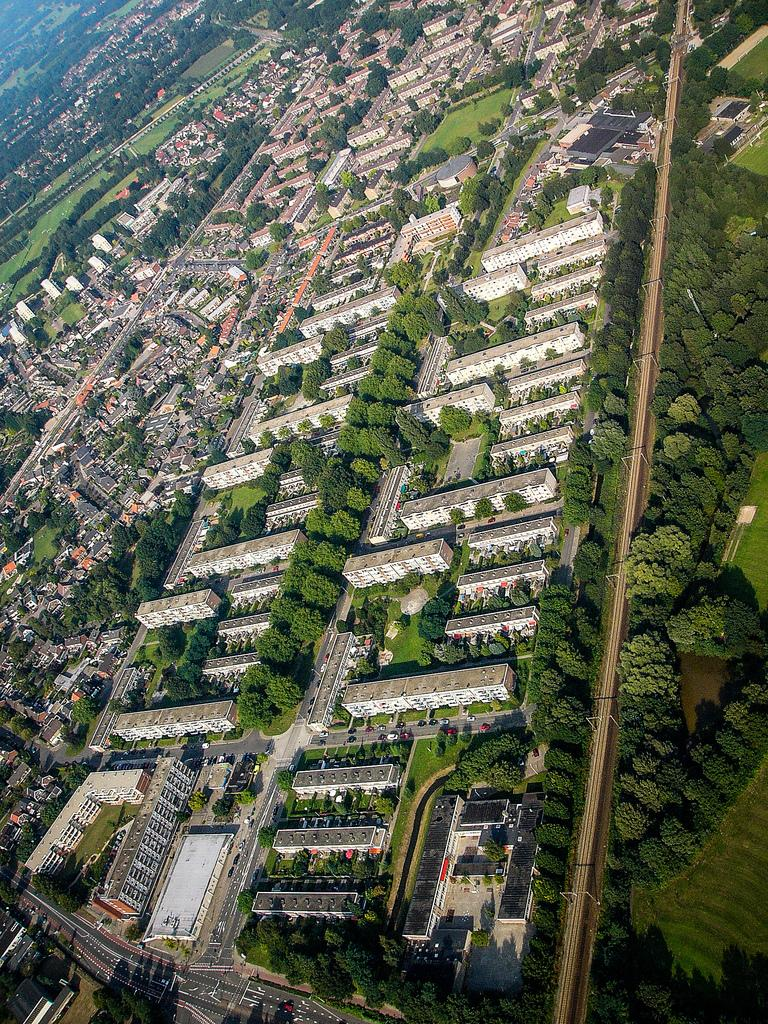What type of structures can be seen in the image? There are buildings in the image. What natural elements are present in the image? There are trees in the image. What man-made objects can be seen in the image? There are poles in the image. What type of transportation infrastructure is visible in the image? There are roads in the image. What type of underwear is hanging on the trees in the image? There is no underwear present in the image; it only features buildings, trees, poles, and roads. How many cherries can be seen on the poles in the image? There are no cherries present on the poles in the image. 